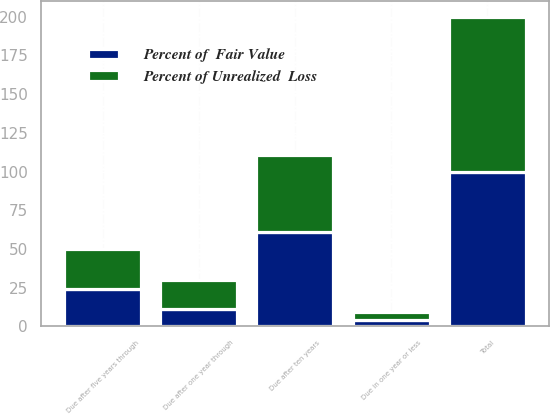Convert chart to OTSL. <chart><loc_0><loc_0><loc_500><loc_500><stacked_bar_chart><ecel><fcel>Due in one year or less<fcel>Due after one year through<fcel>Due after five years through<fcel>Due after ten years<fcel>Total<nl><fcel>Percent of Unrealized  Loss<fcel>5<fcel>19<fcel>26<fcel>50<fcel>100<nl><fcel>Percent of  Fair Value<fcel>4<fcel>11<fcel>24<fcel>61<fcel>100<nl></chart> 